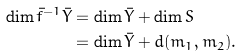<formula> <loc_0><loc_0><loc_500><loc_500>\dim \bar { f } ^ { - 1 } \bar { Y } & = \dim \bar { Y } + \dim S \\ & = \dim \bar { Y } + d ( m _ { 1 } , m _ { 2 } ) .</formula> 